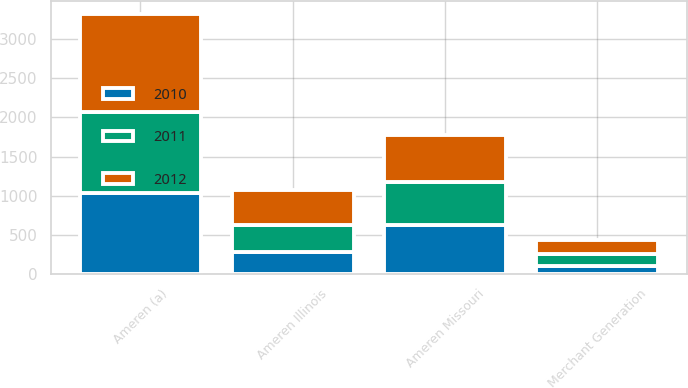Convert chart to OTSL. <chart><loc_0><loc_0><loc_500><loc_500><stacked_bar_chart><ecel><fcel>Ameren (a)<fcel>Ameren Missouri<fcel>Ameren Illinois<fcel>Merchant Generation<nl><fcel>2012<fcel>1240<fcel>595<fcel>442<fcel>178<nl><fcel>2011<fcel>1030<fcel>550<fcel>351<fcel>153<nl><fcel>2010<fcel>1042<fcel>624<fcel>281<fcel>101<nl></chart> 